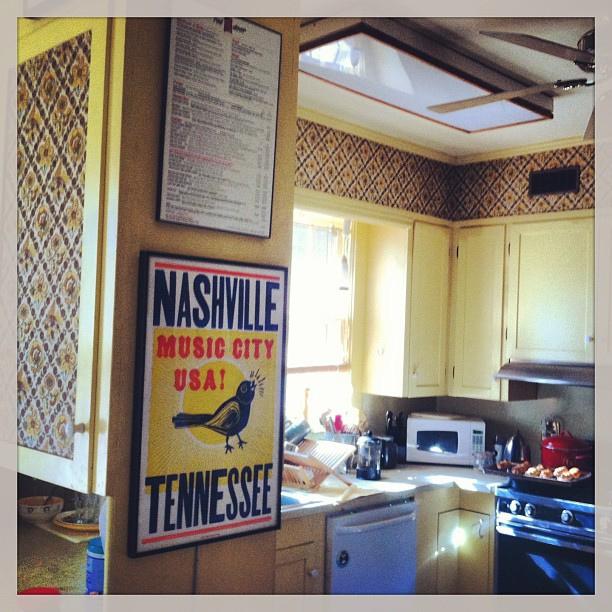How many air vents are there?
Keep it brief. 1. What is being advertised?
Answer briefly. Nashville. What color is the photo?
Write a very short answer. Yellow. What country is mentioned?
Quick response, please. Usa. How many square lights are on the ceiling?
Concise answer only. 1. What kind of sign is in this room?
Short answer required. Nashville. What color is the microwave?
Give a very brief answer. White. What is written on the wooden board?
Short answer required. Nashville. What is in the frame?
Short answer required. Poster. What is sitting atop of the microwave?
Short answer required. Nothing. What kind of light bulb would be necessary for the overhead light?
Quick response, please. Fluorescent. What object is on the bottom left?
Concise answer only. Sign. What is the painting on top a picture of?
Give a very brief answer. Bird. What color is the walls?
Quick response, please. Brown. Is this a restaurant or a home?
Quick response, please. Home. 